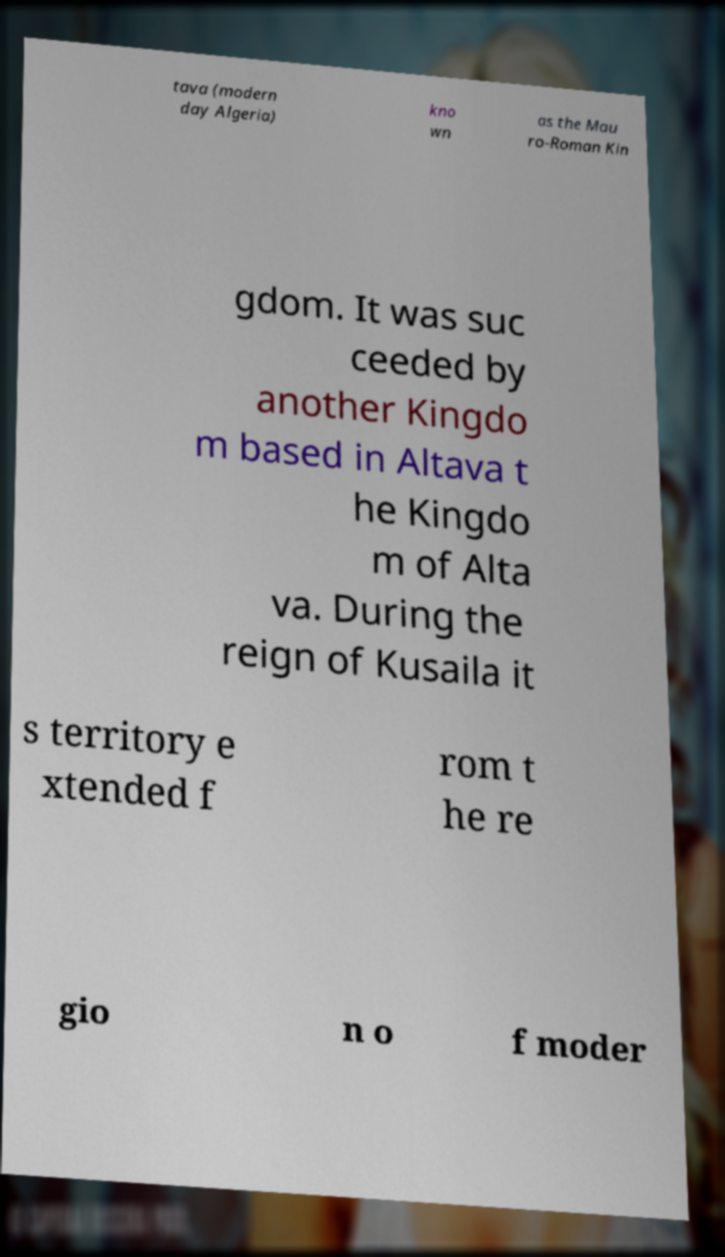Could you extract and type out the text from this image? tava (modern day Algeria) kno wn as the Mau ro-Roman Kin gdom. It was suc ceeded by another Kingdo m based in Altava t he Kingdo m of Alta va. During the reign of Kusaila it s territory e xtended f rom t he re gio n o f moder 